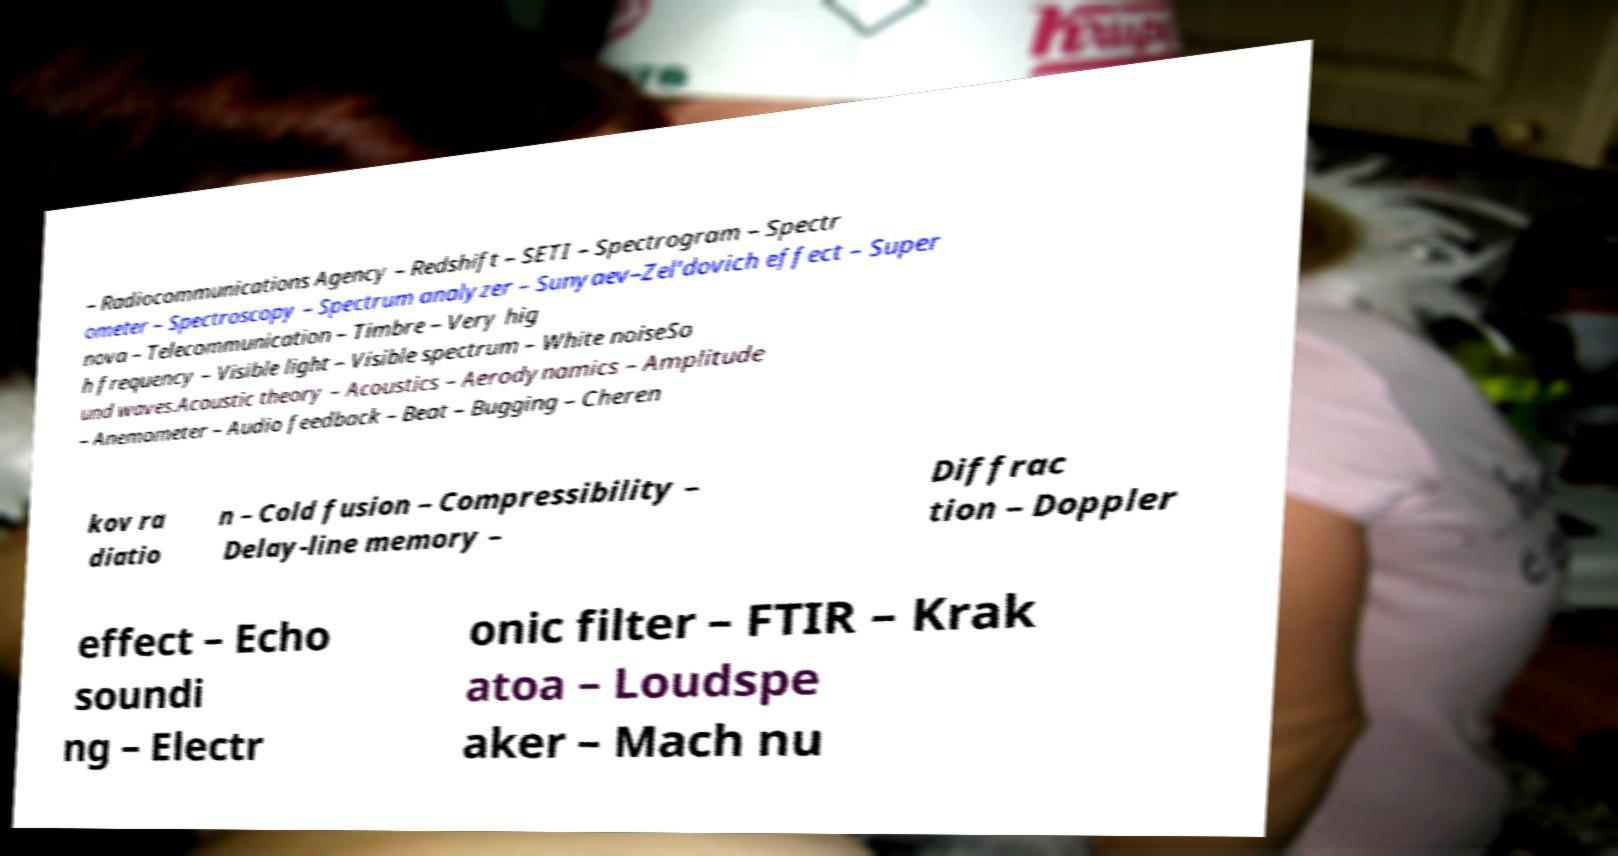Please read and relay the text visible in this image. What does it say? – Radiocommunications Agency – Redshift – SETI – Spectrogram – Spectr ometer – Spectroscopy – Spectrum analyzer – Sunyaev–Zel'dovich effect – Super nova – Telecommunication – Timbre – Very hig h frequency – Visible light – Visible spectrum – White noiseSo und waves.Acoustic theory – Acoustics – Aerodynamics – Amplitude – Anemometer – Audio feedback – Beat – Bugging – Cheren kov ra diatio n – Cold fusion – Compressibility – Delay-line memory – Diffrac tion – Doppler effect – Echo soundi ng – Electr onic filter – FTIR – Krak atoa – Loudspe aker – Mach nu 